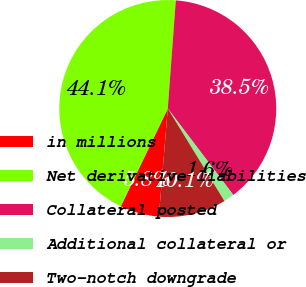Convert chart to OTSL. <chart><loc_0><loc_0><loc_500><loc_500><pie_chart><fcel>in millions<fcel>Net derivative liabilities<fcel>Collateral posted<fcel>Additional collateral or<fcel>Two-notch downgrade<nl><fcel>5.82%<fcel>44.05%<fcel>38.5%<fcel>1.57%<fcel>10.06%<nl></chart> 